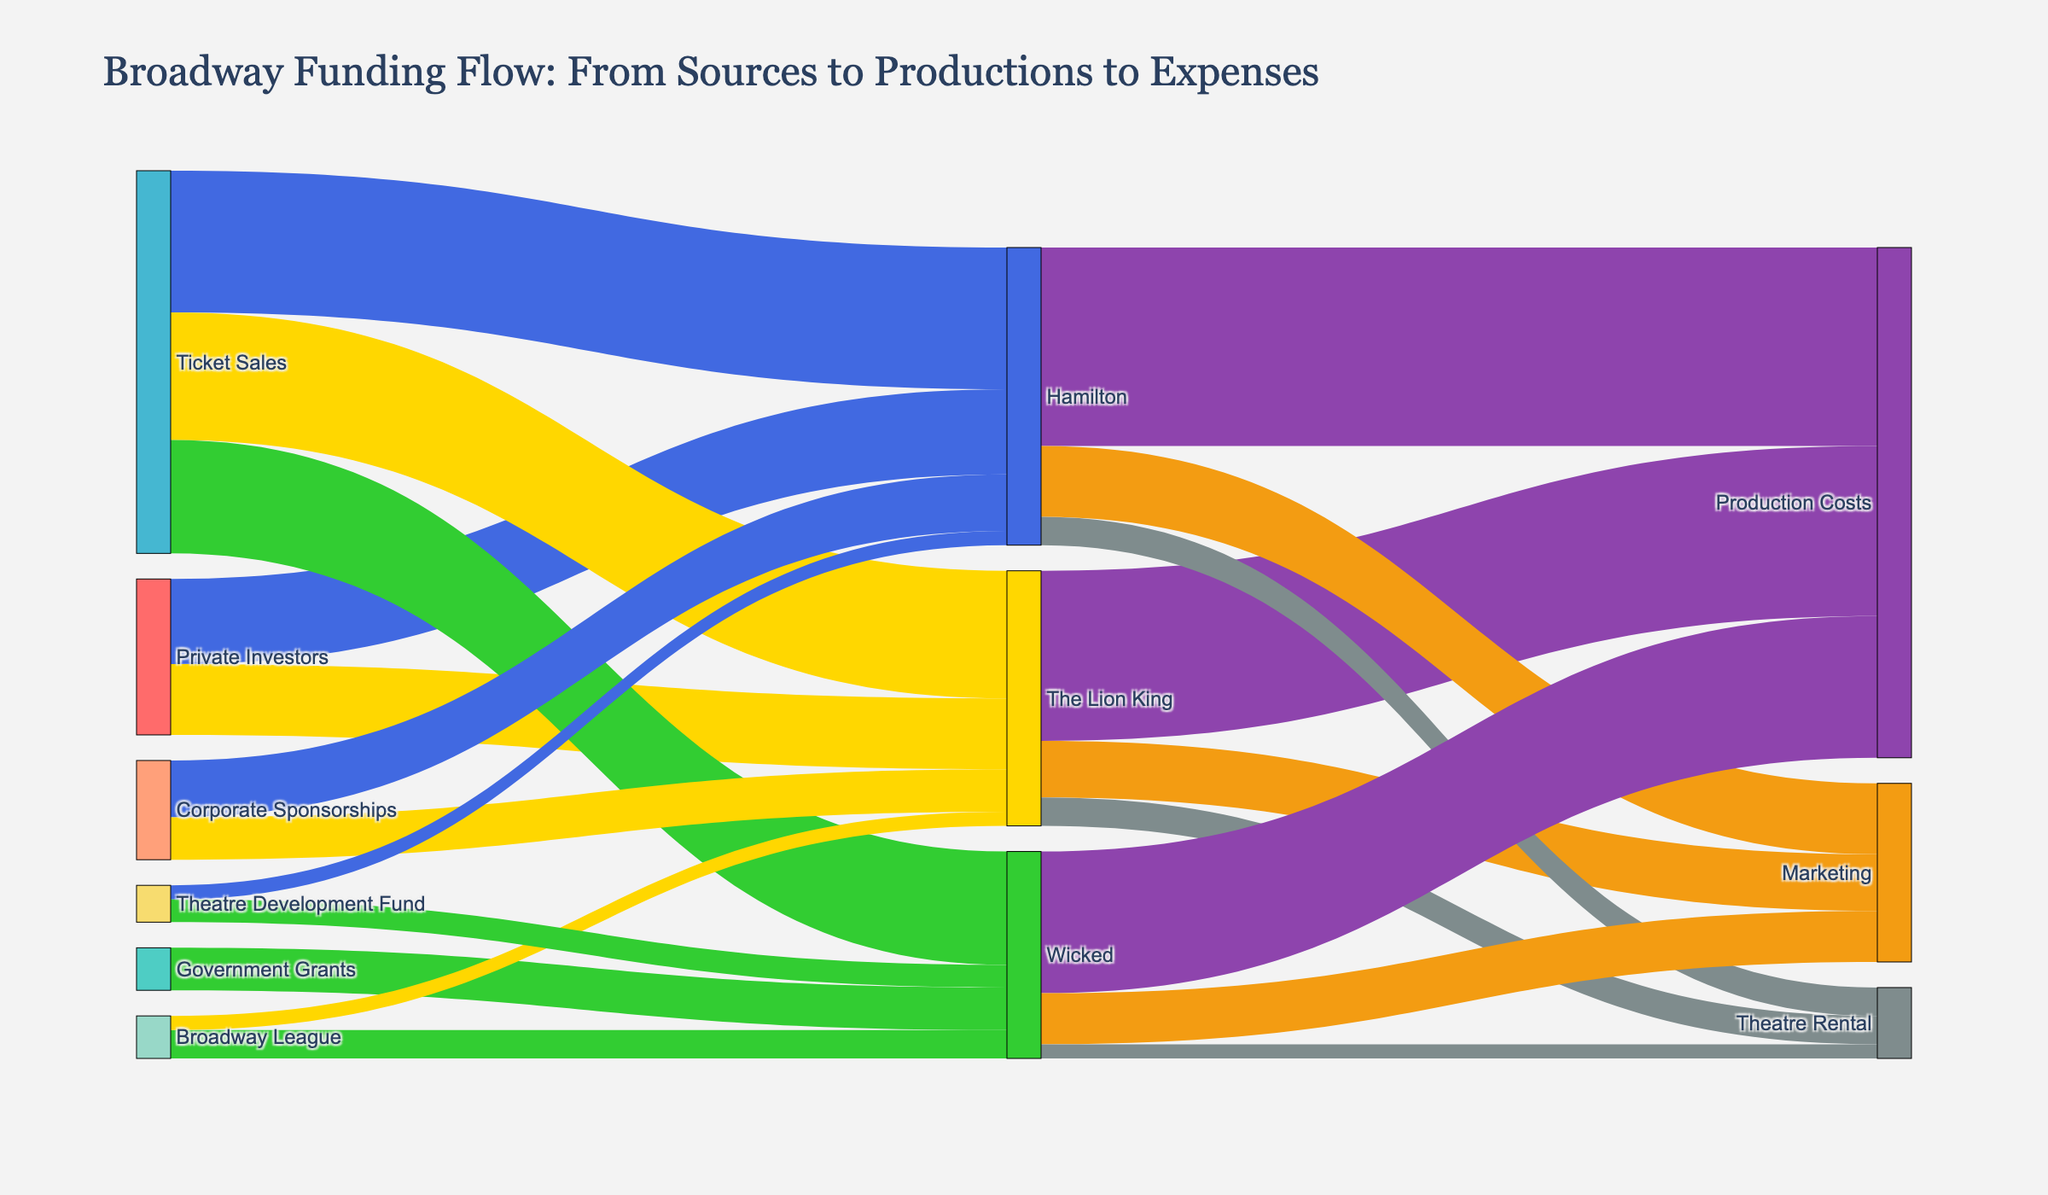Why is The Lion King listed under more than one category? The Lion King is listed under more than one category because its funding comes from multiple sources. By examining the Sankey diagram, we can see different pathways connecting The Lion King to multiple sources like Private Investors, Ticket Sales, Corporate Sponsorships, and Broadway League.
Answer: It has multiple funding sources Which production receives the highest amount from Ticket Sales? To find this, look at the connection pathways from Ticket Sales to the productions. Hamilton, The Lion King, and Wicked all receive funds from Ticket Sales, but the widths of the connection lines indicate that Hamilton receives the most.
Answer: Hamilton What's the total funding received by Hamilton? Sum all the funding amounts flowing into Hamilton from different sources. Hamilton receives 30 from Private Investors, 50 from Ticket Sales, 20 from Corporate Sponsorships, and 5 from Theatre Development Fund, totaling 30 + 50 + 20 + 5 = 105.
Answer: 105 How much more funding does The Lion King receive from Private Investors compared to Wicked from Government Grants? The Lion King receives 25 from Private Investors, while Wicked receives 15 from Government Grants. The difference is calculated as 25 - 15 = 10.
Answer: 10 Compare the marketing expenses for all three productions. Which one spends the least? Look at the funds flowing to the 'Marketing' category for each production. The Lion King spends 20, Hamilton spends 25, and Wicked spends 18. Therefore, Wicked spends the least on marketing.
Answer: Wicked From which source does Wicked receive the second-most funds? By examining the connections flowing into Wicked, we observe that Ticket Sales provide 40, which is the most. The second-most comes from Government Grants, which provide 15.
Answer: Government Grants How does the total expense for Production Costs compare between Hamilton and The Lion King? Hamilton spends 70 on Production Costs, while The Lion King spends 60. Therefore, Hamilton has higher Production Costs by 70 - 60 = 10.
Answer: Hamilton has 10 more What is the ratio of funding received by The Lion King from Corporate Sponsorships to the funding it receives from Broadway League? The Lion King receives 15 from Corporate Sponsorships and 5 from Broadway League. The ratio is calculated as 15 / 5 = 3.
Answer: 3 Which production has the least amount of funding from the Broadway League? By examining the connections, we find that Wicked receives 10 and The Lion King receives 5 from the Broadway League. Hamilton does not receive any funds from the Broadway League. Hence, The Lion King has the least.
Answer: The Lion King How are the expenses for Theatre Rental distributed among the three productions? The connections to 'Theatre Rental' show that each production has separate amounts: The Lion King, Hamilton, and Wicked each spend 10, 10, and 5 respectively. Therefore, Hamilton and The Lion King have equal expenses, and Wicked spends the least.
Answer: The Lion King: 10, Hamilton: 10, Wicked: 5 